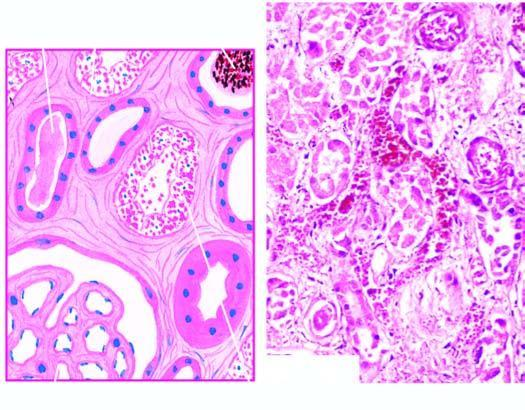what are dilated?
Answer the question using a single word or phrase. Affected tubules 